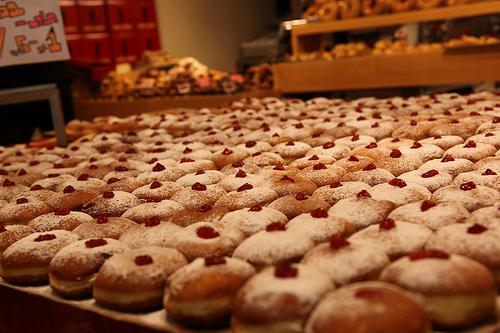Question: what type of food is pictured?
Choices:
A. Cake.
B. Donuts.
C. Candy.
D. Cookies.
Answer with the letter. Answer: B Question: how many different types of filling are on each donut?
Choices:
A. Two.
B. One.
C. Three.
D. Zero.
Answer with the letter. Answer: B Question: what color are the shelves in the background?
Choices:
A. White.
B. Black.
C. Pink.
D. Brown.
Answer with the letter. Answer: D Question: what color poster is on the top left?
Choices:
A. Red.
B. White.
C. Pink.
D. Blue.
Answer with the letter. Answer: B Question: where is the poster?
Choices:
A. On the right.
B. To the left.
C. Near the bottom.
D. Top left.
Answer with the letter. Answer: D 